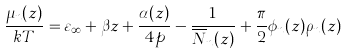Convert formula to latex. <formula><loc_0><loc_0><loc_500><loc_500>\frac { \mu _ { n } ( z ) } { k T } = \varepsilon _ { \infty } + \beta z + \frac { \alpha ( z ) } { 4 p } - \frac { 1 } { \overline { N } _ { n } ( z ) } + \frac { \pi } { 2 } \phi _ { n } ( z ) \rho _ { n } ( z )</formula> 